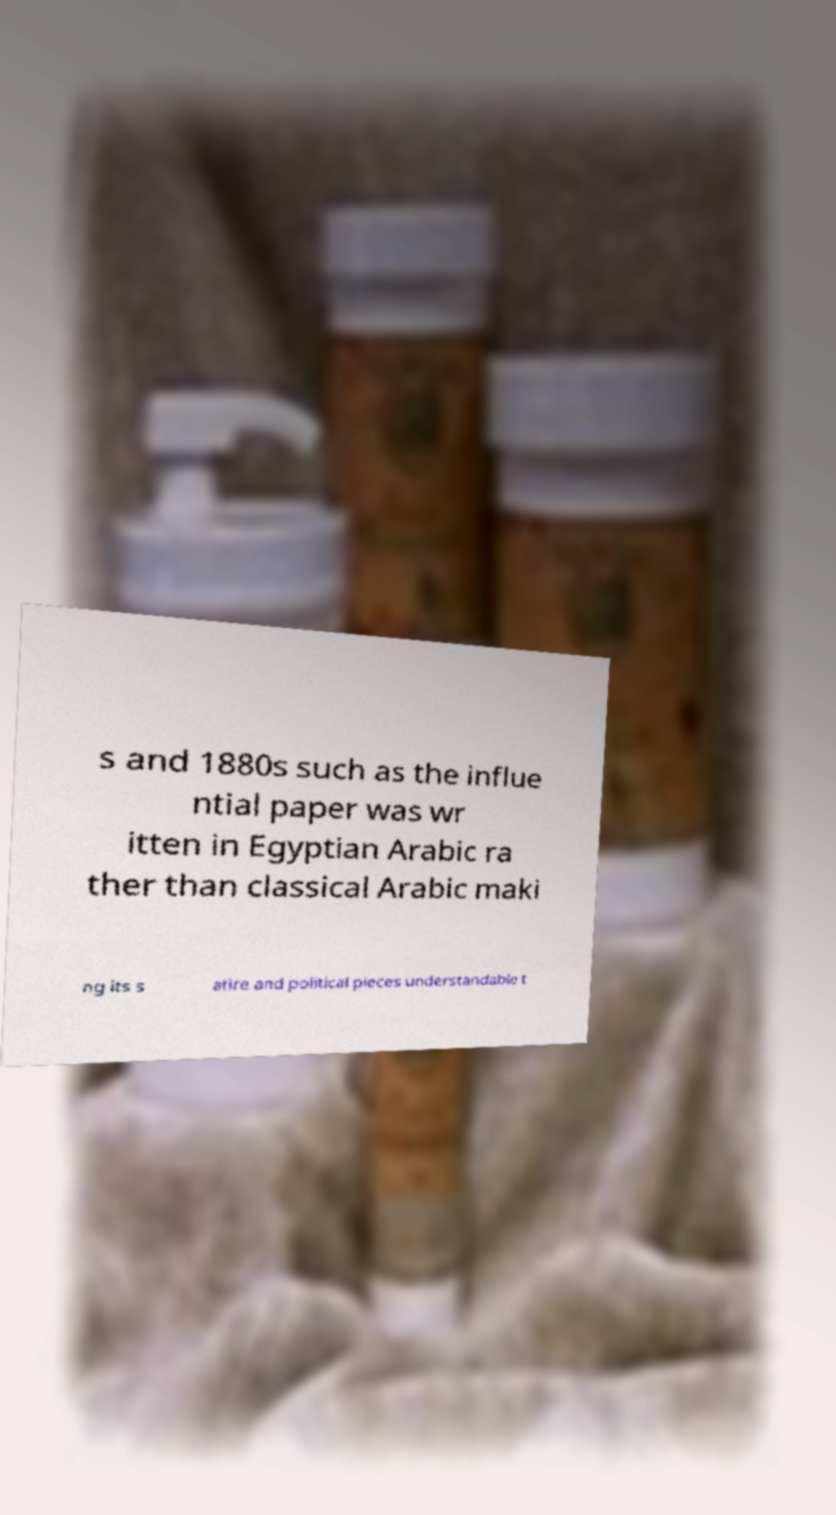Please identify and transcribe the text found in this image. s and 1880s such as the influe ntial paper was wr itten in Egyptian Arabic ra ther than classical Arabic maki ng its s atire and political pieces understandable t 